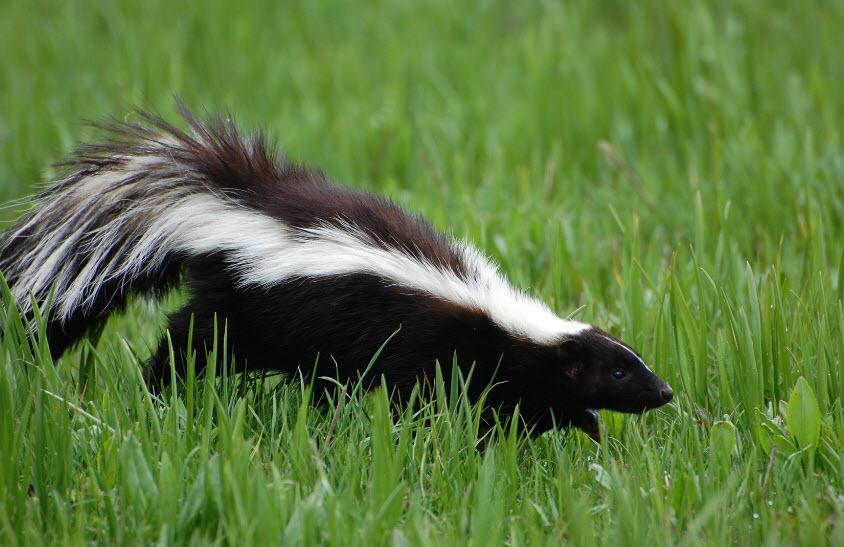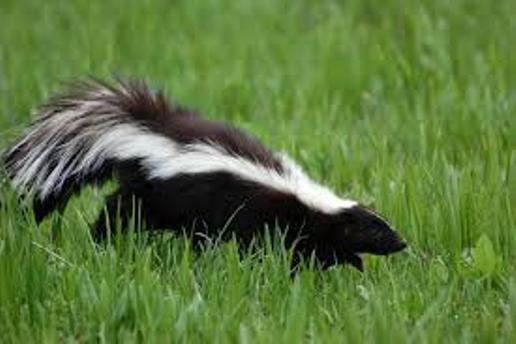The first image is the image on the left, the second image is the image on the right. For the images displayed, is the sentence "There are three skunks in total." factually correct? Answer yes or no. No. The first image is the image on the left, the second image is the image on the right. Analyze the images presented: Is the assertion "There are three skunks." valid? Answer yes or no. No. 